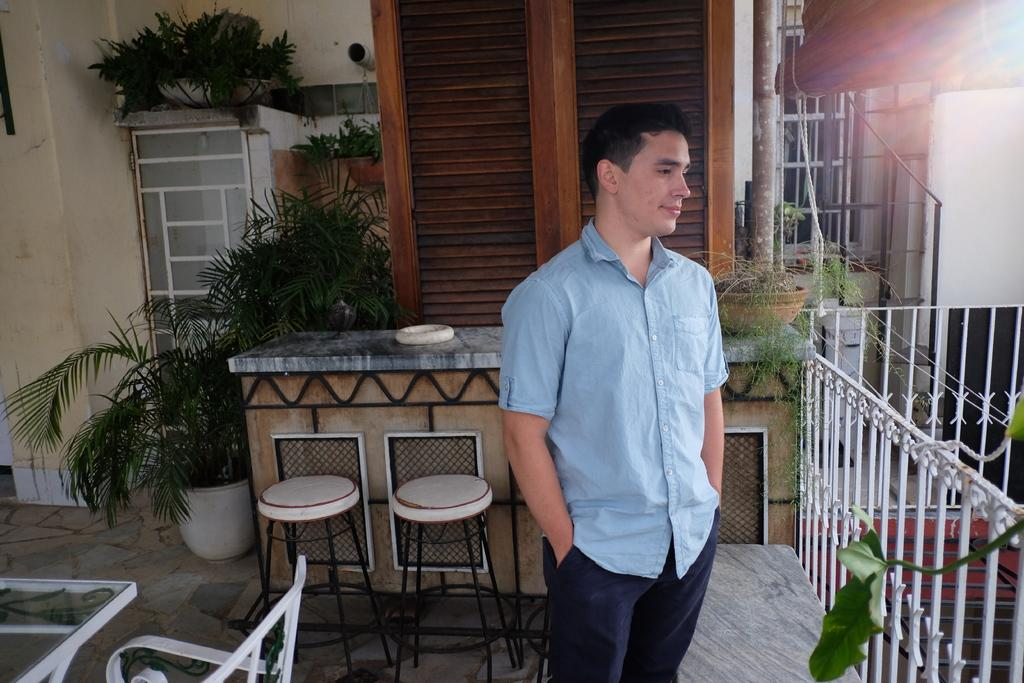What is the main subject of the image? There is a man standing in the image. What is the man doing in the image? The man is looking at something. What type of furniture is present in the image? There is a counter and stools in the image. What type of decorative items can be seen in the image? There are house plants in the image. What type of fuel is being used by the bikes in the image? There are no bikes present in the image, so it is not possible to determine what type of fuel is being used. 